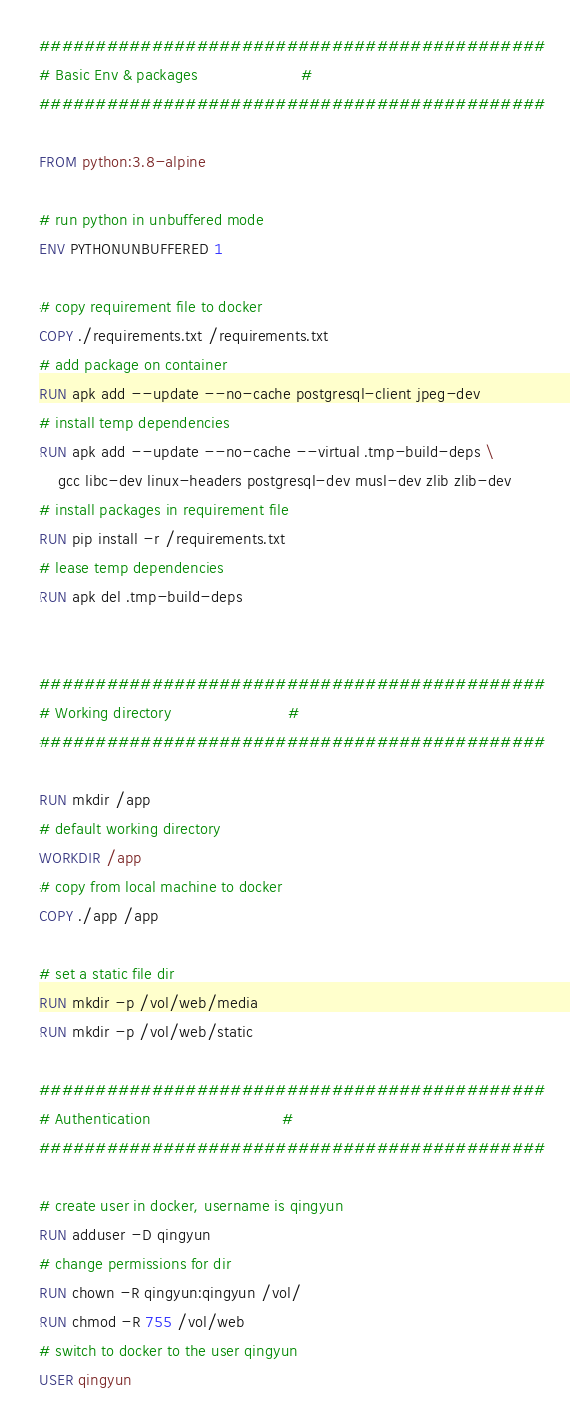Convert code to text. <code><loc_0><loc_0><loc_500><loc_500><_Dockerfile_>#############################################
# Basic Env & packages                      #
#############################################

FROM python:3.8-alpine

# run python in unbuffered mode
ENV PYTHONUNBUFFERED 1

# copy requirement file to docker
COPY ./requirements.txt /requirements.txt
# add package on container
RUN apk add --update --no-cache postgresql-client jpeg-dev
# install temp dependencies
RUN apk add --update --no-cache --virtual .tmp-build-deps \
    gcc libc-dev linux-headers postgresql-dev musl-dev zlib zlib-dev
# install packages in requirement file
RUN pip install -r /requirements.txt
# lease temp dependencies
RUN apk del .tmp-build-deps


#############################################
# Working directory                         #
#############################################

RUN mkdir /app
# default working directory
WORKDIR /app
# copy from local machine to docker
COPY ./app /app

# set a static file dir
RUN mkdir -p /vol/web/media
RUN mkdir -p /vol/web/static

#############################################
# Authentication                            #
#############################################

# create user in docker, username is qingyun
RUN adduser -D qingyun
# change permissions for dir
RUN chown -R qingyun:qingyun /vol/
RUN chmod -R 755 /vol/web
# switch to docker to the user qingyun
USER qingyun</code> 